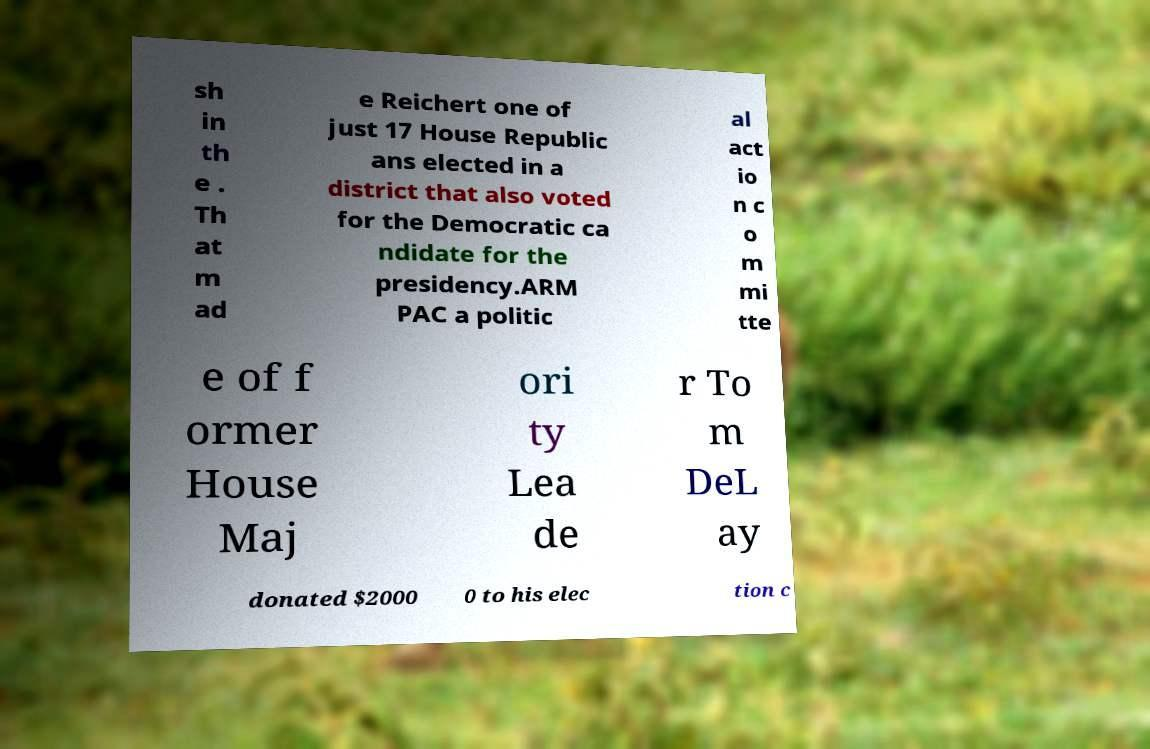Please read and relay the text visible in this image. What does it say? sh in th e . Th at m ad e Reichert one of just 17 House Republic ans elected in a district that also voted for the Democratic ca ndidate for the presidency.ARM PAC a politic al act io n c o m mi tte e of f ormer House Maj ori ty Lea de r To m DeL ay donated $2000 0 to his elec tion c 